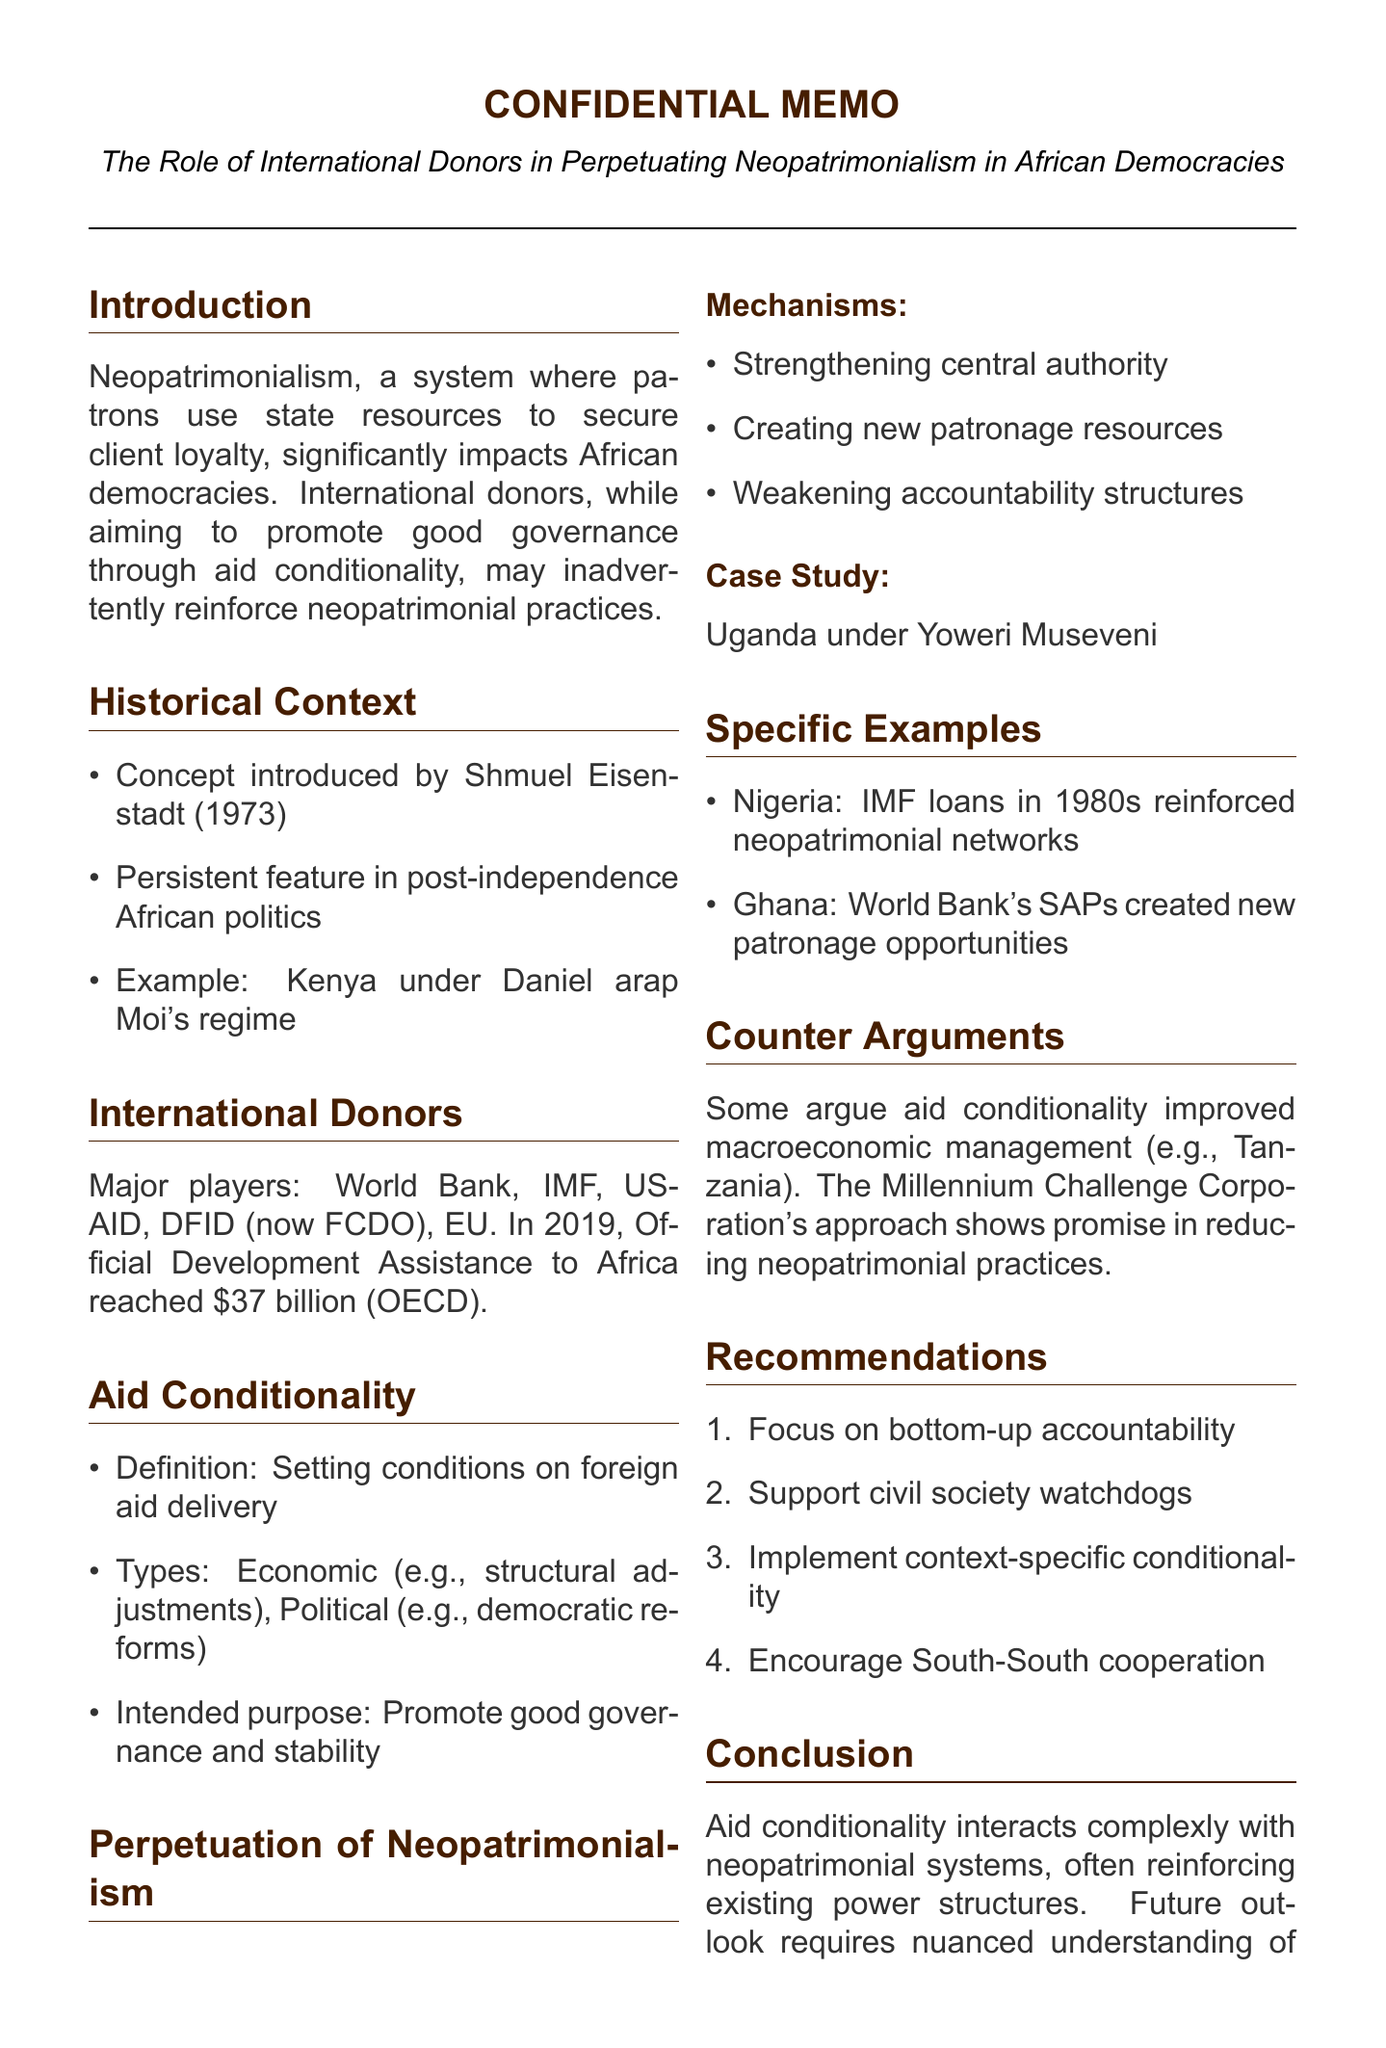What is the definition of neopatrimonialism? Neopatrimonialism is defined as a system of social hierarchy where patrons use state resources to secure the loyalty of clients in the general population.
Answer: A system of social hierarchy where patrons use state resources to secure the loyalty of clients What year was the concept of neopatrimonialism introduced? The document states that the concept was first introduced by Shmuel Eisenstadt in 1973.
Answer: 1973 How much Official Development Assistance did Africa receive in 2019? According to the OECD, Official Development Assistance to Africa reached $37 billion in 2019.
Answer: $37 billion Which country is used as a case study for the role of aid conditionality in neopatrimonialism? The document highlights Uganda under President Yoweri Museveni as a case study.
Answer: Uganda What are the two types of aid conditionality mentioned? The document mentions economic conditionality and political conditionality as the two types.
Answer: Economic conditionality and political conditionality What recommendation emphasizes supporting organizations that act as watchdogs? The recommendation to support civil society organizations that act as watchdogs is specified in the document.
Answer: Support civil society organizations that act as watchdogs Which international donor is mentioned as a major player in the document? The document lists several players including the World Bank, IMF, and USAID among others.
Answer: World Bank What mechanism is mentioned as weakening accountability structures? The document explains that one of the mechanisms is the weakening of accountability structures.
Answer: Weakening of accountability structures What positive impact of aid conditionality is mentioned regarding macroeconomic management? The document notes that some argue aid conditionality has led to improved macroeconomic management in countries like Tanzania.
Answer: Improved macroeconomic management 